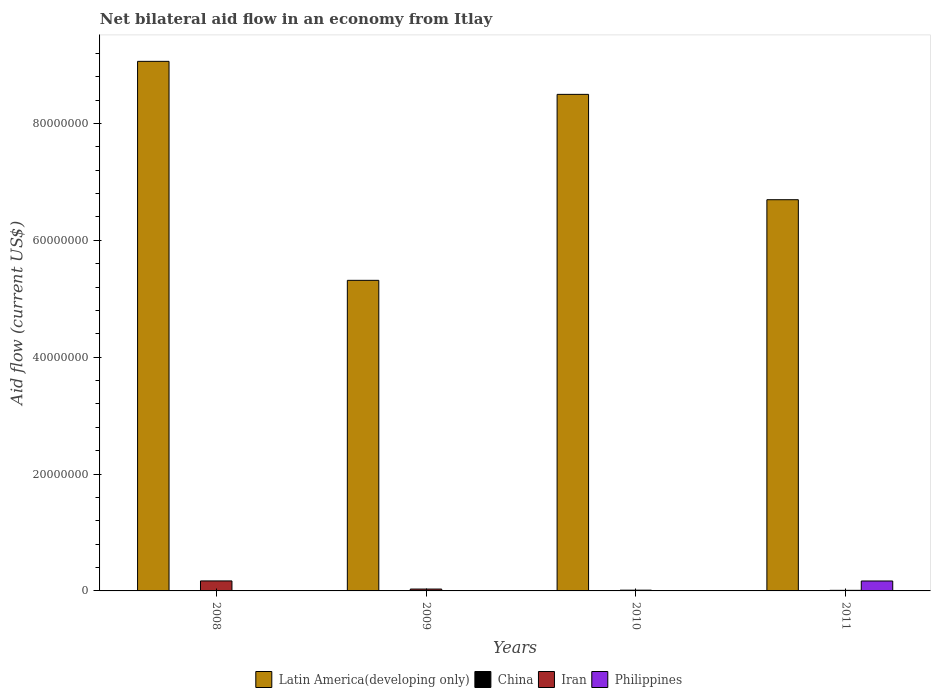Are the number of bars on each tick of the X-axis equal?
Make the answer very short. No. How many bars are there on the 1st tick from the right?
Offer a terse response. 3. In how many cases, is the number of bars for a given year not equal to the number of legend labels?
Make the answer very short. 4. Across all years, what is the maximum net bilateral aid flow in Philippines?
Your answer should be very brief. 1.70e+06. Across all years, what is the minimum net bilateral aid flow in Latin America(developing only)?
Give a very brief answer. 5.32e+07. What is the total net bilateral aid flow in China in the graph?
Provide a short and direct response. 0. What is the difference between the net bilateral aid flow in Iran in 2008 and that in 2011?
Offer a terse response. 1.61e+06. What is the difference between the net bilateral aid flow in Latin America(developing only) in 2011 and the net bilateral aid flow in Philippines in 2010?
Your answer should be compact. 6.70e+07. What is the average net bilateral aid flow in Latin America(developing only) per year?
Give a very brief answer. 7.39e+07. In the year 2011, what is the difference between the net bilateral aid flow in Philippines and net bilateral aid flow in Iran?
Your answer should be compact. 1.60e+06. In how many years, is the net bilateral aid flow in Latin America(developing only) greater than 56000000 US$?
Provide a succinct answer. 3. What is the ratio of the net bilateral aid flow in Latin America(developing only) in 2009 to that in 2011?
Your response must be concise. 0.79. Is the net bilateral aid flow in Iran in 2010 less than that in 2011?
Your response must be concise. No. What is the difference between the highest and the second highest net bilateral aid flow in Latin America(developing only)?
Your answer should be compact. 5.65e+06. What is the difference between the highest and the lowest net bilateral aid flow in Iran?
Your response must be concise. 1.61e+06. In how many years, is the net bilateral aid flow in Philippines greater than the average net bilateral aid flow in Philippines taken over all years?
Provide a short and direct response. 1. Is it the case that in every year, the sum of the net bilateral aid flow in Latin America(developing only) and net bilateral aid flow in Philippines is greater than the net bilateral aid flow in Iran?
Your answer should be compact. Yes. Are the values on the major ticks of Y-axis written in scientific E-notation?
Your response must be concise. No. Does the graph contain grids?
Offer a terse response. No. Where does the legend appear in the graph?
Provide a succinct answer. Bottom center. How many legend labels are there?
Give a very brief answer. 4. What is the title of the graph?
Ensure brevity in your answer.  Net bilateral aid flow in an economy from Itlay. Does "South Asia" appear as one of the legend labels in the graph?
Your answer should be compact. No. What is the label or title of the X-axis?
Offer a very short reply. Years. What is the label or title of the Y-axis?
Your response must be concise. Aid flow (current US$). What is the Aid flow (current US$) of Latin America(developing only) in 2008?
Make the answer very short. 9.06e+07. What is the Aid flow (current US$) in China in 2008?
Offer a very short reply. 0. What is the Aid flow (current US$) of Iran in 2008?
Make the answer very short. 1.71e+06. What is the Aid flow (current US$) of Latin America(developing only) in 2009?
Offer a terse response. 5.32e+07. What is the Aid flow (current US$) in China in 2009?
Give a very brief answer. 0. What is the Aid flow (current US$) of Latin America(developing only) in 2010?
Give a very brief answer. 8.50e+07. What is the Aid flow (current US$) of Iran in 2010?
Offer a terse response. 1.30e+05. What is the Aid flow (current US$) in Philippines in 2010?
Give a very brief answer. 0. What is the Aid flow (current US$) of Latin America(developing only) in 2011?
Make the answer very short. 6.70e+07. What is the Aid flow (current US$) of Philippines in 2011?
Your answer should be very brief. 1.70e+06. Across all years, what is the maximum Aid flow (current US$) of Latin America(developing only)?
Your response must be concise. 9.06e+07. Across all years, what is the maximum Aid flow (current US$) in Iran?
Give a very brief answer. 1.71e+06. Across all years, what is the maximum Aid flow (current US$) in Philippines?
Offer a very short reply. 1.70e+06. Across all years, what is the minimum Aid flow (current US$) in Latin America(developing only)?
Provide a succinct answer. 5.32e+07. What is the total Aid flow (current US$) in Latin America(developing only) in the graph?
Your response must be concise. 2.96e+08. What is the total Aid flow (current US$) in Iran in the graph?
Your answer should be very brief. 2.26e+06. What is the total Aid flow (current US$) in Philippines in the graph?
Your answer should be very brief. 1.70e+06. What is the difference between the Aid flow (current US$) of Latin America(developing only) in 2008 and that in 2009?
Offer a very short reply. 3.75e+07. What is the difference between the Aid flow (current US$) in Iran in 2008 and that in 2009?
Make the answer very short. 1.39e+06. What is the difference between the Aid flow (current US$) in Latin America(developing only) in 2008 and that in 2010?
Provide a succinct answer. 5.65e+06. What is the difference between the Aid flow (current US$) in Iran in 2008 and that in 2010?
Ensure brevity in your answer.  1.58e+06. What is the difference between the Aid flow (current US$) in Latin America(developing only) in 2008 and that in 2011?
Your response must be concise. 2.37e+07. What is the difference between the Aid flow (current US$) of Iran in 2008 and that in 2011?
Offer a terse response. 1.61e+06. What is the difference between the Aid flow (current US$) of Latin America(developing only) in 2009 and that in 2010?
Offer a terse response. -3.18e+07. What is the difference between the Aid flow (current US$) in Iran in 2009 and that in 2010?
Your answer should be very brief. 1.90e+05. What is the difference between the Aid flow (current US$) in Latin America(developing only) in 2009 and that in 2011?
Your answer should be very brief. -1.38e+07. What is the difference between the Aid flow (current US$) of Latin America(developing only) in 2010 and that in 2011?
Offer a very short reply. 1.80e+07. What is the difference between the Aid flow (current US$) in Iran in 2010 and that in 2011?
Make the answer very short. 3.00e+04. What is the difference between the Aid flow (current US$) in Latin America(developing only) in 2008 and the Aid flow (current US$) in Iran in 2009?
Your response must be concise. 9.03e+07. What is the difference between the Aid flow (current US$) in Latin America(developing only) in 2008 and the Aid flow (current US$) in Iran in 2010?
Keep it short and to the point. 9.05e+07. What is the difference between the Aid flow (current US$) of Latin America(developing only) in 2008 and the Aid flow (current US$) of Iran in 2011?
Offer a very short reply. 9.05e+07. What is the difference between the Aid flow (current US$) of Latin America(developing only) in 2008 and the Aid flow (current US$) of Philippines in 2011?
Your answer should be very brief. 8.89e+07. What is the difference between the Aid flow (current US$) of Latin America(developing only) in 2009 and the Aid flow (current US$) of Iran in 2010?
Your response must be concise. 5.30e+07. What is the difference between the Aid flow (current US$) of Latin America(developing only) in 2009 and the Aid flow (current US$) of Iran in 2011?
Keep it short and to the point. 5.31e+07. What is the difference between the Aid flow (current US$) in Latin America(developing only) in 2009 and the Aid flow (current US$) in Philippines in 2011?
Ensure brevity in your answer.  5.15e+07. What is the difference between the Aid flow (current US$) of Iran in 2009 and the Aid flow (current US$) of Philippines in 2011?
Provide a short and direct response. -1.38e+06. What is the difference between the Aid flow (current US$) of Latin America(developing only) in 2010 and the Aid flow (current US$) of Iran in 2011?
Provide a succinct answer. 8.49e+07. What is the difference between the Aid flow (current US$) in Latin America(developing only) in 2010 and the Aid flow (current US$) in Philippines in 2011?
Your response must be concise. 8.33e+07. What is the difference between the Aid flow (current US$) of Iran in 2010 and the Aid flow (current US$) of Philippines in 2011?
Offer a very short reply. -1.57e+06. What is the average Aid flow (current US$) in Latin America(developing only) per year?
Ensure brevity in your answer.  7.39e+07. What is the average Aid flow (current US$) of Iran per year?
Keep it short and to the point. 5.65e+05. What is the average Aid flow (current US$) of Philippines per year?
Provide a succinct answer. 4.25e+05. In the year 2008, what is the difference between the Aid flow (current US$) of Latin America(developing only) and Aid flow (current US$) of Iran?
Offer a very short reply. 8.89e+07. In the year 2009, what is the difference between the Aid flow (current US$) of Latin America(developing only) and Aid flow (current US$) of Iran?
Give a very brief answer. 5.28e+07. In the year 2010, what is the difference between the Aid flow (current US$) of Latin America(developing only) and Aid flow (current US$) of Iran?
Your response must be concise. 8.49e+07. In the year 2011, what is the difference between the Aid flow (current US$) of Latin America(developing only) and Aid flow (current US$) of Iran?
Provide a succinct answer. 6.69e+07. In the year 2011, what is the difference between the Aid flow (current US$) of Latin America(developing only) and Aid flow (current US$) of Philippines?
Give a very brief answer. 6.53e+07. In the year 2011, what is the difference between the Aid flow (current US$) in Iran and Aid flow (current US$) in Philippines?
Offer a very short reply. -1.60e+06. What is the ratio of the Aid flow (current US$) in Latin America(developing only) in 2008 to that in 2009?
Make the answer very short. 1.71. What is the ratio of the Aid flow (current US$) in Iran in 2008 to that in 2009?
Your response must be concise. 5.34. What is the ratio of the Aid flow (current US$) of Latin America(developing only) in 2008 to that in 2010?
Your answer should be compact. 1.07. What is the ratio of the Aid flow (current US$) of Iran in 2008 to that in 2010?
Provide a short and direct response. 13.15. What is the ratio of the Aid flow (current US$) in Latin America(developing only) in 2008 to that in 2011?
Make the answer very short. 1.35. What is the ratio of the Aid flow (current US$) of Latin America(developing only) in 2009 to that in 2010?
Offer a terse response. 0.63. What is the ratio of the Aid flow (current US$) in Iran in 2009 to that in 2010?
Offer a very short reply. 2.46. What is the ratio of the Aid flow (current US$) in Latin America(developing only) in 2009 to that in 2011?
Your response must be concise. 0.79. What is the ratio of the Aid flow (current US$) in Iran in 2009 to that in 2011?
Your response must be concise. 3.2. What is the ratio of the Aid flow (current US$) of Latin America(developing only) in 2010 to that in 2011?
Your answer should be very brief. 1.27. What is the ratio of the Aid flow (current US$) of Iran in 2010 to that in 2011?
Your answer should be very brief. 1.3. What is the difference between the highest and the second highest Aid flow (current US$) in Latin America(developing only)?
Keep it short and to the point. 5.65e+06. What is the difference between the highest and the second highest Aid flow (current US$) of Iran?
Give a very brief answer. 1.39e+06. What is the difference between the highest and the lowest Aid flow (current US$) of Latin America(developing only)?
Provide a short and direct response. 3.75e+07. What is the difference between the highest and the lowest Aid flow (current US$) in Iran?
Your answer should be very brief. 1.61e+06. What is the difference between the highest and the lowest Aid flow (current US$) of Philippines?
Your answer should be compact. 1.70e+06. 